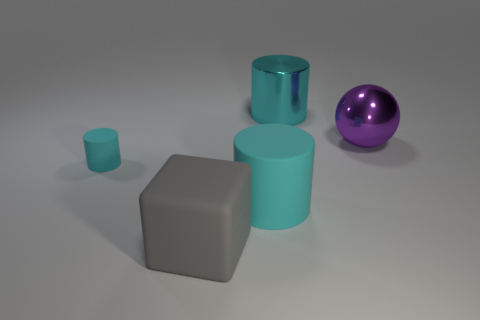Add 3 rubber balls. How many objects exist? 8 Subtract all blocks. How many objects are left? 4 Subtract 0 red cylinders. How many objects are left? 5 Subtract all small cyan rubber cylinders. Subtract all small cyan cylinders. How many objects are left? 3 Add 3 cyan shiny cylinders. How many cyan shiny cylinders are left? 4 Add 5 large metallic cylinders. How many large metallic cylinders exist? 6 